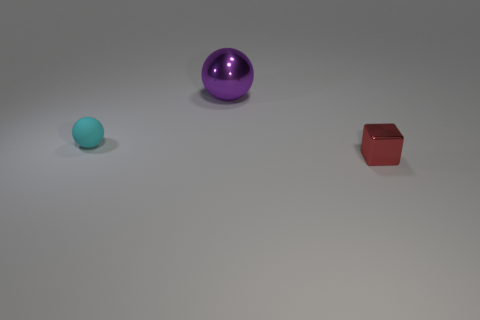Subtract all balls. How many objects are left? 1 Subtract 1 blocks. How many blocks are left? 0 Add 2 big brown matte cylinders. How many objects exist? 5 Subtract all brown blocks. Subtract all cyan spheres. How many blocks are left? 1 Subtract all cyan cylinders. How many purple balls are left? 1 Subtract all brown shiny balls. Subtract all small things. How many objects are left? 1 Add 3 small red cubes. How many small red cubes are left? 4 Add 3 matte cylinders. How many matte cylinders exist? 3 Subtract 0 red spheres. How many objects are left? 3 